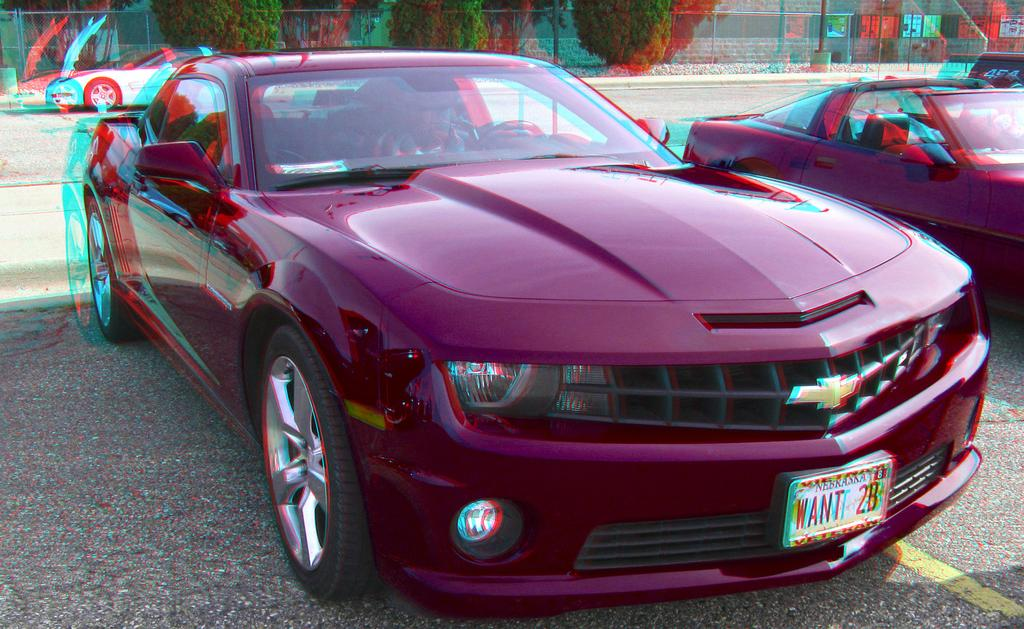What is blocking the path in the image? There are cars parked on the path in the image. What can be seen in the background of the image? There are plants, trees, a wire fence, and a building in the background of the image. What type of plough is being used to maintain the trees in the image? There is no plough present in the image, and the trees are not being maintained in any visible way. 